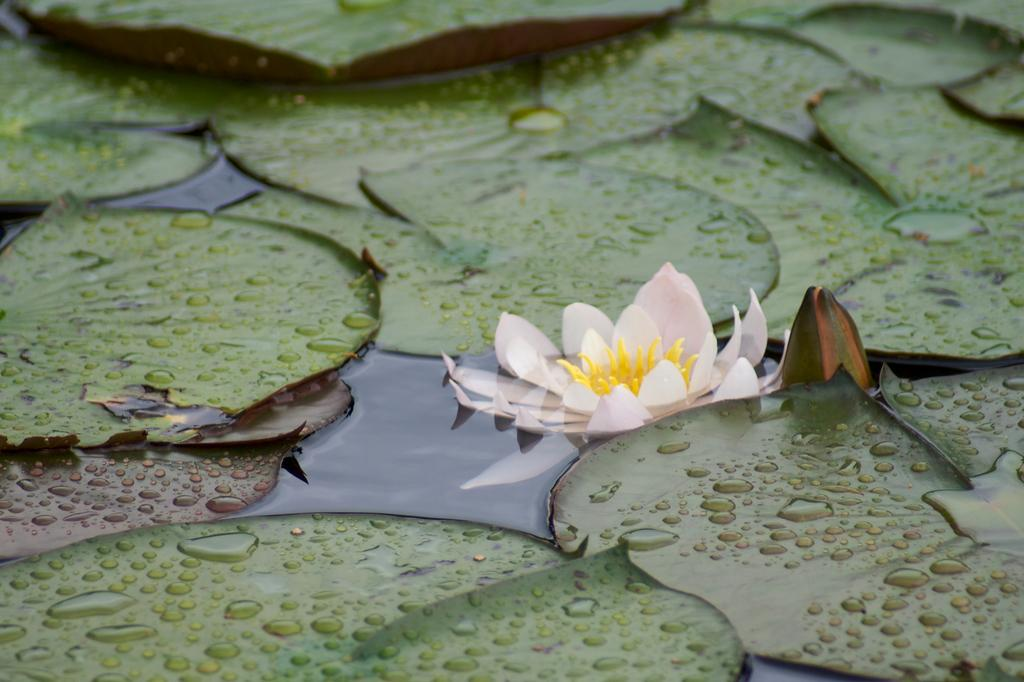What type of plant can be seen in the image? There is a flower in the image. What colors are present on the flower? The flower has yellow and light pink colors. What else is visible in the image besides the flower? There are leaves in the image. What color are the leaves? The leaves are green in color. Where are the leaves located in relation to the flower? The leaves are on the water. What is the chance of the flower being able to open a drawer in the image? There is no mention of a drawer or any action involving the flower in the image, so it is not possible to determine the chance of the flower opening a drawer. 